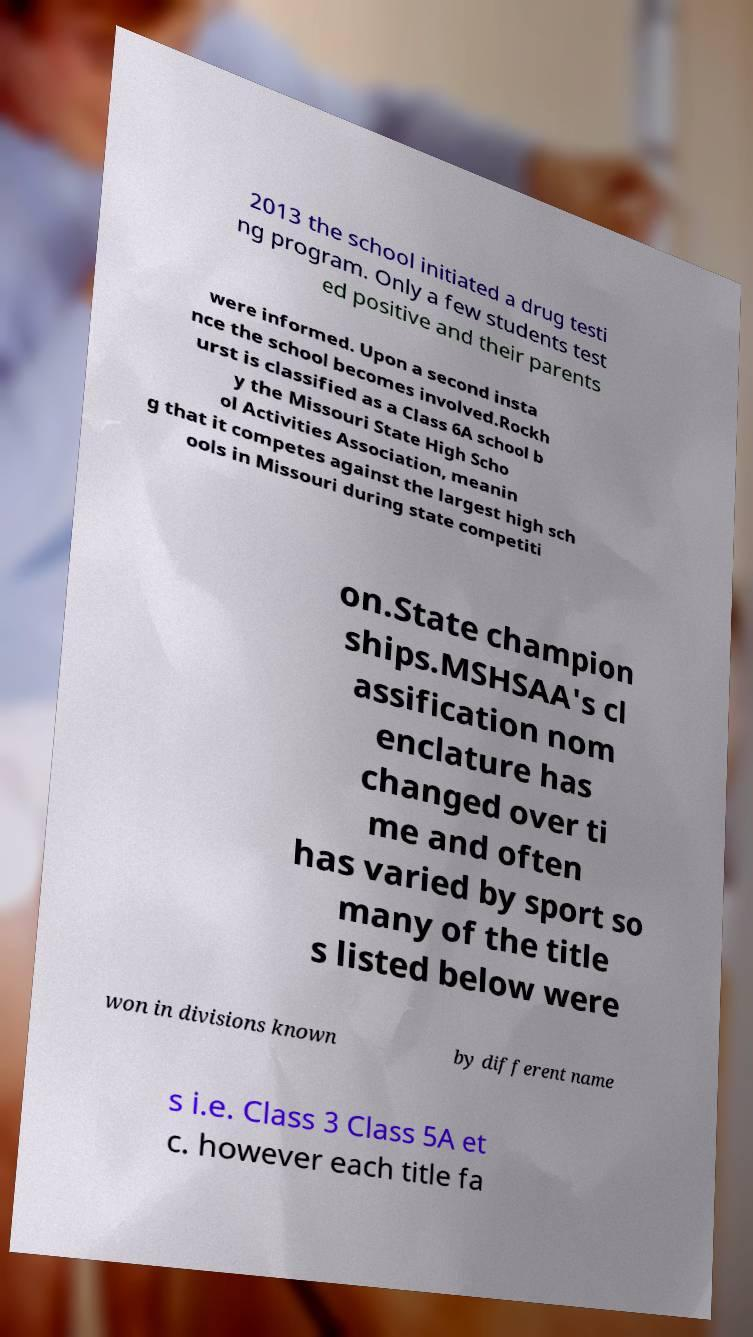Can you read and provide the text displayed in the image?This photo seems to have some interesting text. Can you extract and type it out for me? 2013 the school initiated a drug testi ng program. Only a few students test ed positive and their parents were informed. Upon a second insta nce the school becomes involved.Rockh urst is classified as a Class 6A school b y the Missouri State High Scho ol Activities Association, meanin g that it competes against the largest high sch ools in Missouri during state competiti on.State champion ships.MSHSAA's cl assification nom enclature has changed over ti me and often has varied by sport so many of the title s listed below were won in divisions known by different name s i.e. Class 3 Class 5A et c. however each title fa 